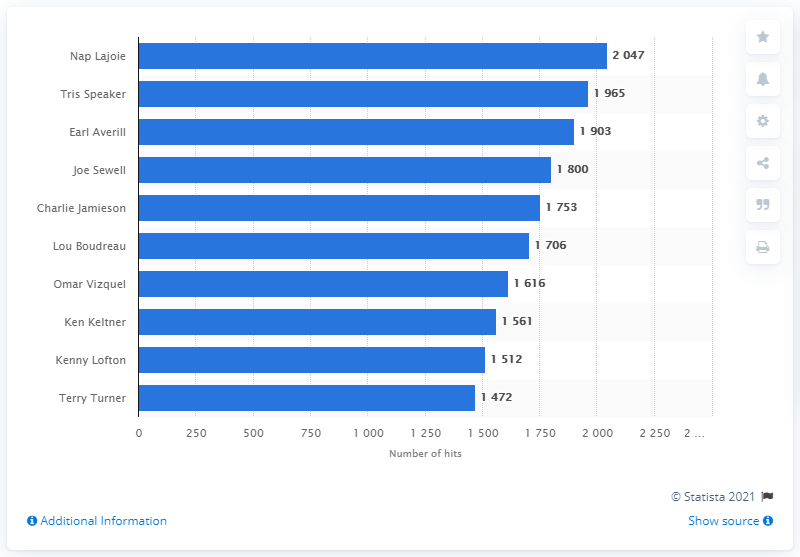Draw attention to some important aspects in this diagram. Nap Lajoie holds the record for the most hits in the history of the Cleveland Indians franchise. 